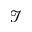<formula> <loc_0><loc_0><loc_500><loc_500>\mathcal { I }</formula> 